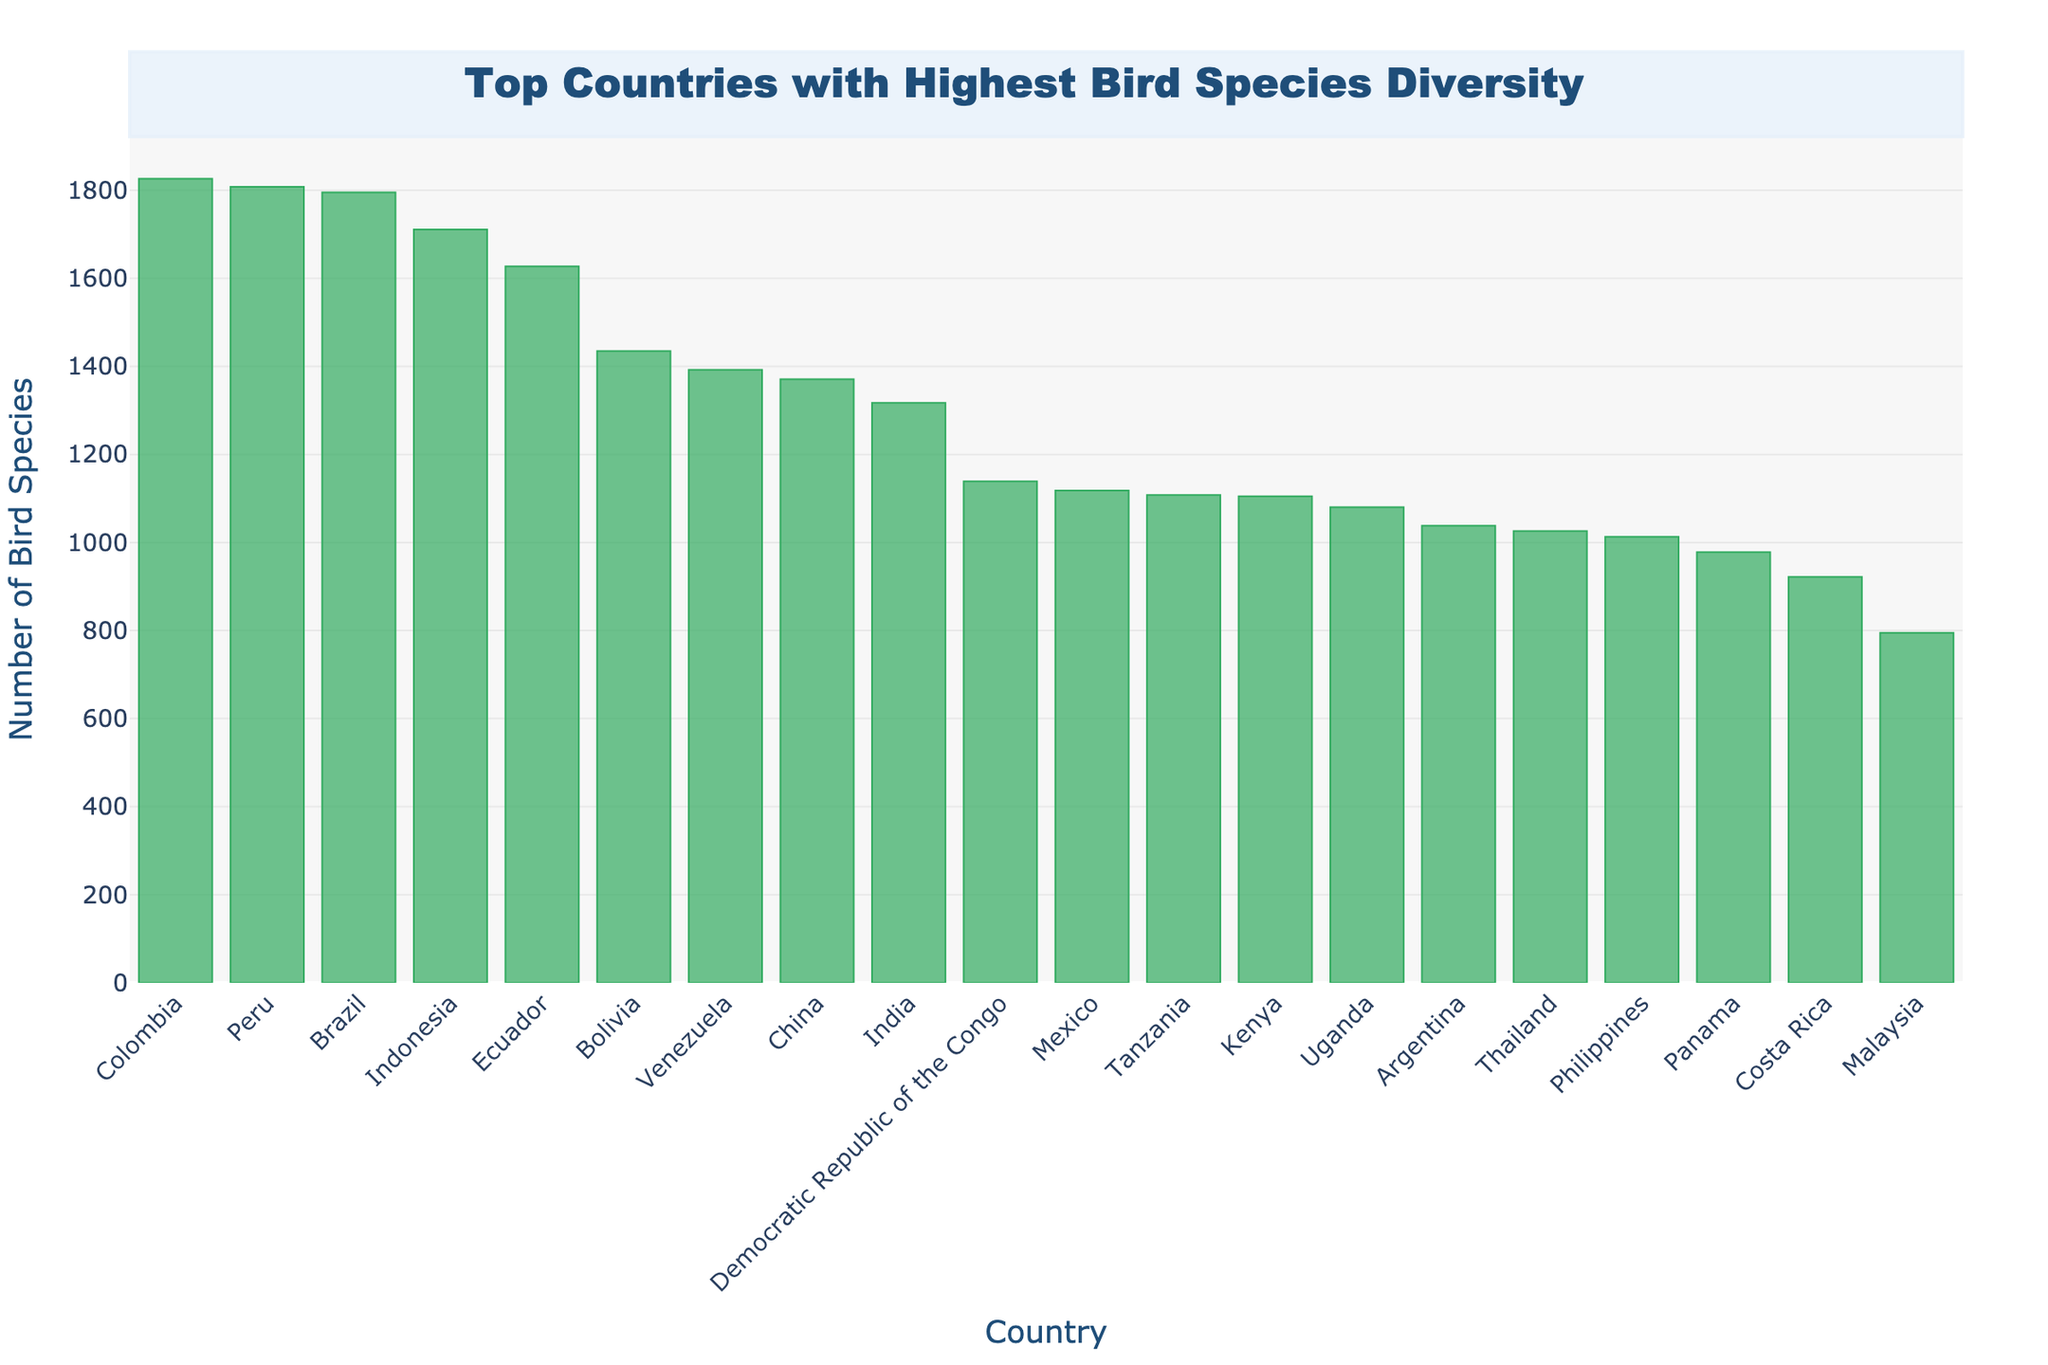Which country has the highest bird species diversity? The bar for Colombia is the tallest on the chart, indicating it has the highest bird species count.
Answer: Colombia How many more bird species does Peru have than Uganda? From the chart, Peru has 1808 species and Uganda has 1080 species. The difference is 1808 - 1080 = 728.
Answer: 728 Which country ranks third in terms of bird species diversity? The third tallest bar corresponds to Brazil, indicating it is third in bird species diversity.
Answer: Brazil What is the total bird species count for the top two countries combined? Colombia has 1826 species and Peru has 1808 species. Summing them up gives 1826 + 1808 = 3634.
Answer: 3634 Is India’s bird species count greater than China’s? India's position on the bar chart is lower than China's, indicating India has fewer bird species than China.
Answer: No Which has more bird species: Ecuador or Venezuela? The bar for Ecuador is taller than the bar for Venezuela, indicating Ecuador has more bird species.
Answer: Ecuador What is the average bird species count for the top three countries? Summing the counts for Colombia, Peru, and Brazil: 1826 + 1808 + 1795 = 5429. Dividing by 3 gives 5429 / 3 = 1809.67
Answer: 1809.67 What is the difference in bird species count between the country with the fourth and the fifth highest diversity? Indonesia has 1711 species and Ecuador has 1627 species. The difference is 1711 - 1627 = 84.
Answer: 84 Which two countries have bird species counts closest to each other? The bars for Tanzania and Kenya appear very close in height; Tanzania has 1108 species and Kenya has 1105 species, a difference of just 3.
Answer: Tanzania and Kenya If combined, would the bird species counts of the countries ranked ninth and tenth surpass the top country? India's count is 1317, and the Democratic Republic of the Congo's count is 1139. Combined, they have 1317 + 1139 = 2456, which is more than Colombia's 1826.
Answer: Yes 